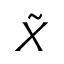Convert formula to latex. <formula><loc_0><loc_0><loc_500><loc_500>\tilde { X }</formula> 